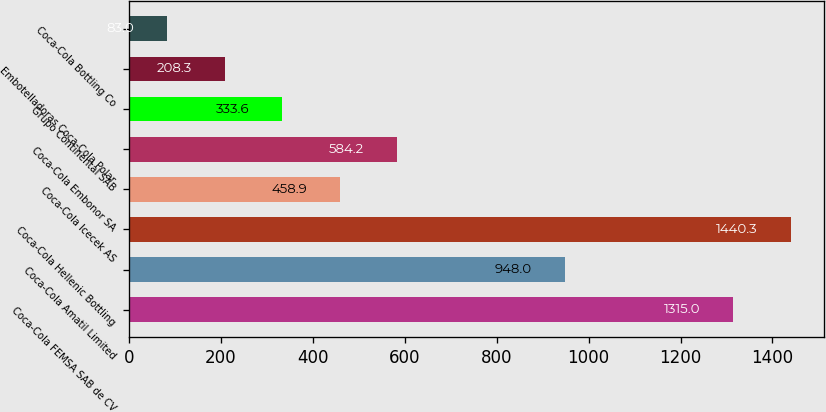<chart> <loc_0><loc_0><loc_500><loc_500><bar_chart><fcel>Coca-Cola FEMSA SAB de CV<fcel>Coca-Cola Amatil Limited<fcel>Coca-Cola Hellenic Bottling<fcel>Coca-Cola Icecek AS<fcel>Coca-Cola Embonor SA<fcel>Grupo Continental SAB<fcel>Embotelladoras Coca-Cola Polar<fcel>Coca-Cola Bottling Co<nl><fcel>1315<fcel>948<fcel>1440.3<fcel>458.9<fcel>584.2<fcel>333.6<fcel>208.3<fcel>83<nl></chart> 